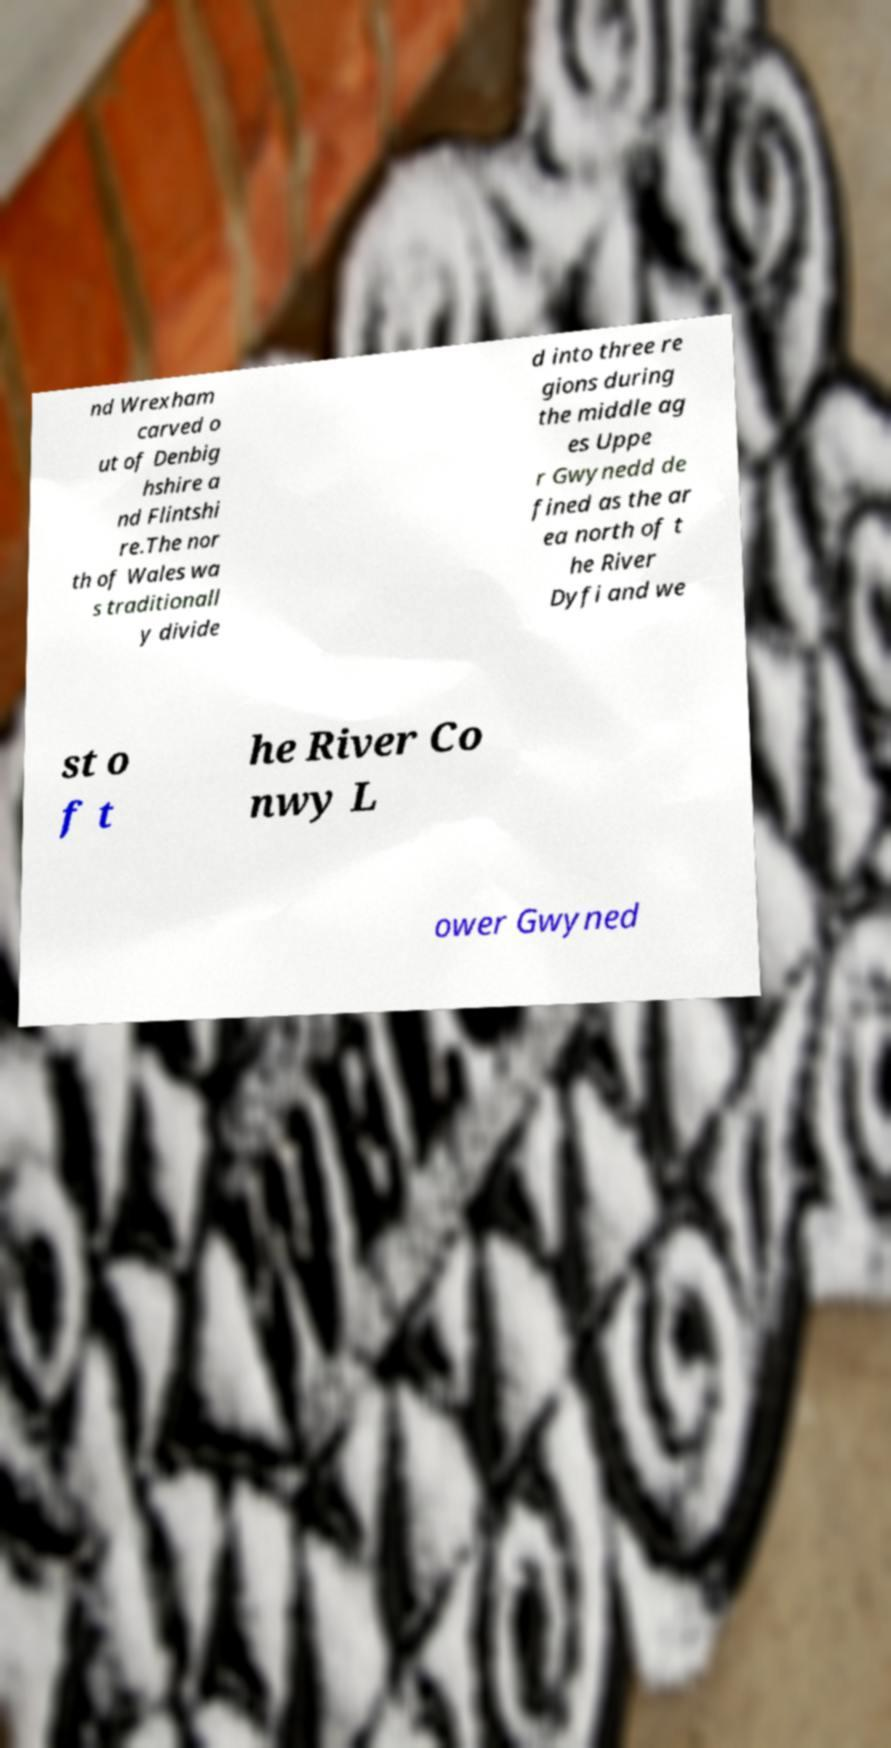Can you accurately transcribe the text from the provided image for me? nd Wrexham carved o ut of Denbig hshire a nd Flintshi re.The nor th of Wales wa s traditionall y divide d into three re gions during the middle ag es Uppe r Gwynedd de fined as the ar ea north of t he River Dyfi and we st o f t he River Co nwy L ower Gwyned 